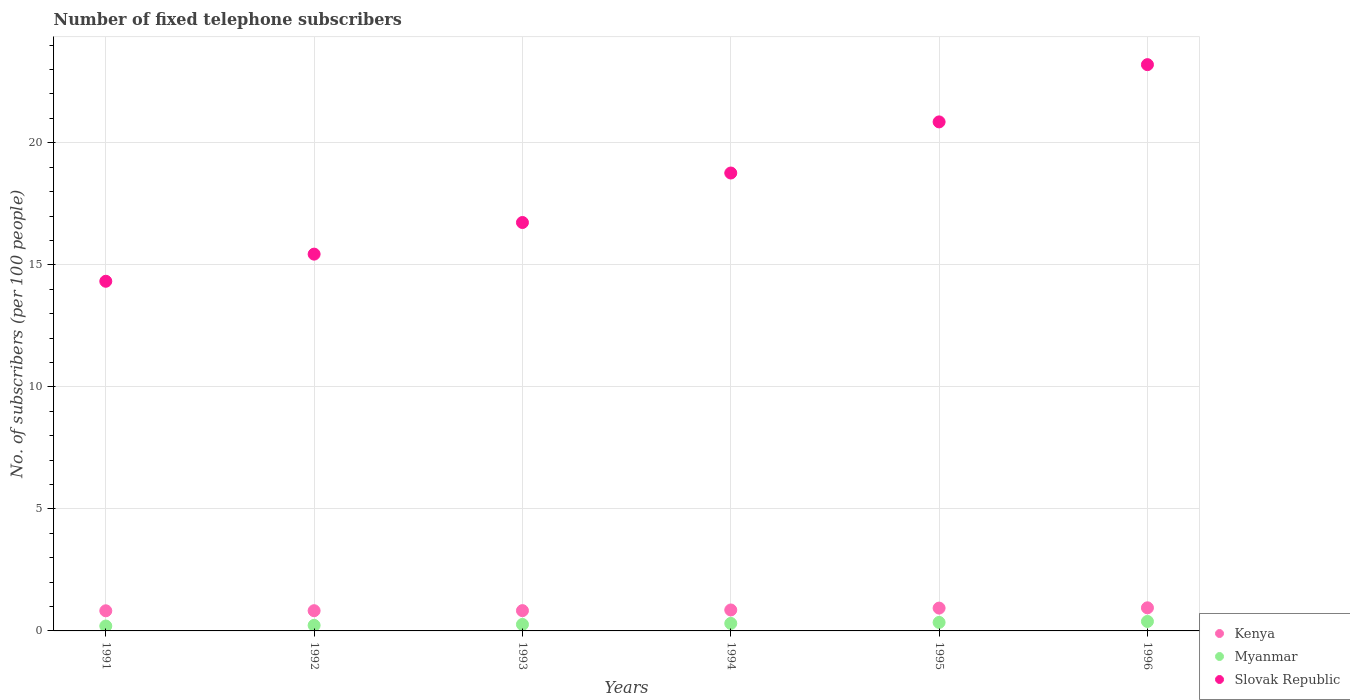How many different coloured dotlines are there?
Your answer should be very brief. 3. What is the number of fixed telephone subscribers in Slovak Republic in 1991?
Ensure brevity in your answer.  14.33. Across all years, what is the maximum number of fixed telephone subscribers in Kenya?
Offer a terse response. 0.95. Across all years, what is the minimum number of fixed telephone subscribers in Myanmar?
Provide a succinct answer. 0.2. In which year was the number of fixed telephone subscribers in Slovak Republic maximum?
Your response must be concise. 1996. What is the total number of fixed telephone subscribers in Kenya in the graph?
Your response must be concise. 5.22. What is the difference between the number of fixed telephone subscribers in Kenya in 1991 and that in 1994?
Offer a very short reply. -0.03. What is the difference between the number of fixed telephone subscribers in Kenya in 1995 and the number of fixed telephone subscribers in Myanmar in 1996?
Ensure brevity in your answer.  0.55. What is the average number of fixed telephone subscribers in Slovak Republic per year?
Keep it short and to the point. 18.22. In the year 1992, what is the difference between the number of fixed telephone subscribers in Myanmar and number of fixed telephone subscribers in Kenya?
Offer a terse response. -0.6. In how many years, is the number of fixed telephone subscribers in Kenya greater than 22?
Offer a very short reply. 0. What is the ratio of the number of fixed telephone subscribers in Kenya in 1993 to that in 1994?
Give a very brief answer. 0.97. Is the number of fixed telephone subscribers in Slovak Republic in 1991 less than that in 1994?
Your answer should be compact. Yes. Is the difference between the number of fixed telephone subscribers in Myanmar in 1991 and 1995 greater than the difference between the number of fixed telephone subscribers in Kenya in 1991 and 1995?
Offer a terse response. No. What is the difference between the highest and the second highest number of fixed telephone subscribers in Myanmar?
Provide a succinct answer. 0.04. What is the difference between the highest and the lowest number of fixed telephone subscribers in Kenya?
Your response must be concise. 0.12. In how many years, is the number of fixed telephone subscribers in Myanmar greater than the average number of fixed telephone subscribers in Myanmar taken over all years?
Your answer should be compact. 3. Is it the case that in every year, the sum of the number of fixed telephone subscribers in Kenya and number of fixed telephone subscribers in Myanmar  is greater than the number of fixed telephone subscribers in Slovak Republic?
Offer a very short reply. No. Is the number of fixed telephone subscribers in Kenya strictly greater than the number of fixed telephone subscribers in Slovak Republic over the years?
Provide a short and direct response. No. Is the number of fixed telephone subscribers in Slovak Republic strictly less than the number of fixed telephone subscribers in Kenya over the years?
Make the answer very short. No. How many years are there in the graph?
Your answer should be compact. 6. What is the difference between two consecutive major ticks on the Y-axis?
Provide a succinct answer. 5. Are the values on the major ticks of Y-axis written in scientific E-notation?
Your answer should be compact. No. Does the graph contain grids?
Provide a short and direct response. Yes. Where does the legend appear in the graph?
Make the answer very short. Bottom right. How many legend labels are there?
Give a very brief answer. 3. How are the legend labels stacked?
Offer a terse response. Vertical. What is the title of the graph?
Give a very brief answer. Number of fixed telephone subscribers. What is the label or title of the Y-axis?
Offer a very short reply. No. of subscribers (per 100 people). What is the No. of subscribers (per 100 people) of Kenya in 1991?
Your answer should be compact. 0.83. What is the No. of subscribers (per 100 people) in Myanmar in 1991?
Ensure brevity in your answer.  0.2. What is the No. of subscribers (per 100 people) of Slovak Republic in 1991?
Your response must be concise. 14.33. What is the No. of subscribers (per 100 people) in Kenya in 1992?
Provide a short and direct response. 0.83. What is the No. of subscribers (per 100 people) of Myanmar in 1992?
Your answer should be very brief. 0.23. What is the No. of subscribers (per 100 people) in Slovak Republic in 1992?
Keep it short and to the point. 15.44. What is the No. of subscribers (per 100 people) of Kenya in 1993?
Offer a very short reply. 0.83. What is the No. of subscribers (per 100 people) of Myanmar in 1993?
Your response must be concise. 0.27. What is the No. of subscribers (per 100 people) in Slovak Republic in 1993?
Offer a very short reply. 16.73. What is the No. of subscribers (per 100 people) in Kenya in 1994?
Offer a terse response. 0.86. What is the No. of subscribers (per 100 people) in Myanmar in 1994?
Make the answer very short. 0.31. What is the No. of subscribers (per 100 people) in Slovak Republic in 1994?
Offer a terse response. 18.76. What is the No. of subscribers (per 100 people) in Kenya in 1995?
Keep it short and to the point. 0.94. What is the No. of subscribers (per 100 people) of Myanmar in 1995?
Give a very brief answer. 0.35. What is the No. of subscribers (per 100 people) in Slovak Republic in 1995?
Offer a very short reply. 20.86. What is the No. of subscribers (per 100 people) of Kenya in 1996?
Your answer should be compact. 0.95. What is the No. of subscribers (per 100 people) of Myanmar in 1996?
Make the answer very short. 0.39. What is the No. of subscribers (per 100 people) of Slovak Republic in 1996?
Offer a very short reply. 23.2. Across all years, what is the maximum No. of subscribers (per 100 people) of Kenya?
Offer a terse response. 0.95. Across all years, what is the maximum No. of subscribers (per 100 people) in Myanmar?
Ensure brevity in your answer.  0.39. Across all years, what is the maximum No. of subscribers (per 100 people) of Slovak Republic?
Make the answer very short. 23.2. Across all years, what is the minimum No. of subscribers (per 100 people) of Kenya?
Make the answer very short. 0.83. Across all years, what is the minimum No. of subscribers (per 100 people) of Myanmar?
Your response must be concise. 0.2. Across all years, what is the minimum No. of subscribers (per 100 people) of Slovak Republic?
Your answer should be compact. 14.33. What is the total No. of subscribers (per 100 people) in Kenya in the graph?
Your answer should be compact. 5.22. What is the total No. of subscribers (per 100 people) in Myanmar in the graph?
Offer a terse response. 1.74. What is the total No. of subscribers (per 100 people) in Slovak Republic in the graph?
Offer a terse response. 109.32. What is the difference between the No. of subscribers (per 100 people) of Kenya in 1991 and that in 1992?
Offer a very short reply. -0. What is the difference between the No. of subscribers (per 100 people) of Myanmar in 1991 and that in 1992?
Keep it short and to the point. -0.03. What is the difference between the No. of subscribers (per 100 people) in Slovak Republic in 1991 and that in 1992?
Offer a very short reply. -1.11. What is the difference between the No. of subscribers (per 100 people) of Kenya in 1991 and that in 1993?
Provide a succinct answer. -0.01. What is the difference between the No. of subscribers (per 100 people) in Myanmar in 1991 and that in 1993?
Offer a very short reply. -0.07. What is the difference between the No. of subscribers (per 100 people) of Slovak Republic in 1991 and that in 1993?
Make the answer very short. -2.41. What is the difference between the No. of subscribers (per 100 people) of Kenya in 1991 and that in 1994?
Your answer should be very brief. -0.03. What is the difference between the No. of subscribers (per 100 people) in Myanmar in 1991 and that in 1994?
Provide a short and direct response. -0.11. What is the difference between the No. of subscribers (per 100 people) in Slovak Republic in 1991 and that in 1994?
Provide a short and direct response. -4.44. What is the difference between the No. of subscribers (per 100 people) in Kenya in 1991 and that in 1995?
Your answer should be compact. -0.11. What is the difference between the No. of subscribers (per 100 people) of Myanmar in 1991 and that in 1995?
Provide a succinct answer. -0.15. What is the difference between the No. of subscribers (per 100 people) of Slovak Republic in 1991 and that in 1995?
Keep it short and to the point. -6.53. What is the difference between the No. of subscribers (per 100 people) of Kenya in 1991 and that in 1996?
Offer a very short reply. -0.12. What is the difference between the No. of subscribers (per 100 people) of Myanmar in 1991 and that in 1996?
Offer a very short reply. -0.19. What is the difference between the No. of subscribers (per 100 people) in Slovak Republic in 1991 and that in 1996?
Give a very brief answer. -8.88. What is the difference between the No. of subscribers (per 100 people) in Kenya in 1992 and that in 1993?
Offer a very short reply. -0. What is the difference between the No. of subscribers (per 100 people) in Myanmar in 1992 and that in 1993?
Your answer should be compact. -0.04. What is the difference between the No. of subscribers (per 100 people) of Slovak Republic in 1992 and that in 1993?
Your answer should be very brief. -1.3. What is the difference between the No. of subscribers (per 100 people) in Kenya in 1992 and that in 1994?
Offer a terse response. -0.03. What is the difference between the No. of subscribers (per 100 people) in Myanmar in 1992 and that in 1994?
Your response must be concise. -0.08. What is the difference between the No. of subscribers (per 100 people) in Slovak Republic in 1992 and that in 1994?
Make the answer very short. -3.32. What is the difference between the No. of subscribers (per 100 people) of Kenya in 1992 and that in 1995?
Provide a succinct answer. -0.11. What is the difference between the No. of subscribers (per 100 people) of Myanmar in 1992 and that in 1995?
Provide a succinct answer. -0.12. What is the difference between the No. of subscribers (per 100 people) of Slovak Republic in 1992 and that in 1995?
Offer a terse response. -5.42. What is the difference between the No. of subscribers (per 100 people) of Kenya in 1992 and that in 1996?
Make the answer very short. -0.12. What is the difference between the No. of subscribers (per 100 people) in Myanmar in 1992 and that in 1996?
Make the answer very short. -0.16. What is the difference between the No. of subscribers (per 100 people) in Slovak Republic in 1992 and that in 1996?
Provide a short and direct response. -7.76. What is the difference between the No. of subscribers (per 100 people) of Kenya in 1993 and that in 1994?
Your response must be concise. -0.03. What is the difference between the No. of subscribers (per 100 people) of Myanmar in 1993 and that in 1994?
Give a very brief answer. -0.04. What is the difference between the No. of subscribers (per 100 people) in Slovak Republic in 1993 and that in 1994?
Offer a very short reply. -2.03. What is the difference between the No. of subscribers (per 100 people) of Kenya in 1993 and that in 1995?
Your answer should be compact. -0.1. What is the difference between the No. of subscribers (per 100 people) of Myanmar in 1993 and that in 1995?
Provide a short and direct response. -0.08. What is the difference between the No. of subscribers (per 100 people) of Slovak Republic in 1993 and that in 1995?
Offer a terse response. -4.12. What is the difference between the No. of subscribers (per 100 people) in Kenya in 1993 and that in 1996?
Provide a succinct answer. -0.12. What is the difference between the No. of subscribers (per 100 people) of Myanmar in 1993 and that in 1996?
Offer a terse response. -0.12. What is the difference between the No. of subscribers (per 100 people) of Slovak Republic in 1993 and that in 1996?
Provide a short and direct response. -6.47. What is the difference between the No. of subscribers (per 100 people) of Kenya in 1994 and that in 1995?
Provide a succinct answer. -0.08. What is the difference between the No. of subscribers (per 100 people) in Myanmar in 1994 and that in 1995?
Make the answer very short. -0.04. What is the difference between the No. of subscribers (per 100 people) of Slovak Republic in 1994 and that in 1995?
Your response must be concise. -2.09. What is the difference between the No. of subscribers (per 100 people) of Kenya in 1994 and that in 1996?
Your answer should be very brief. -0.09. What is the difference between the No. of subscribers (per 100 people) in Myanmar in 1994 and that in 1996?
Your answer should be compact. -0.08. What is the difference between the No. of subscribers (per 100 people) of Slovak Republic in 1994 and that in 1996?
Your answer should be very brief. -4.44. What is the difference between the No. of subscribers (per 100 people) in Kenya in 1995 and that in 1996?
Provide a short and direct response. -0.01. What is the difference between the No. of subscribers (per 100 people) of Myanmar in 1995 and that in 1996?
Your response must be concise. -0.04. What is the difference between the No. of subscribers (per 100 people) in Slovak Republic in 1995 and that in 1996?
Your answer should be very brief. -2.35. What is the difference between the No. of subscribers (per 100 people) in Kenya in 1991 and the No. of subscribers (per 100 people) in Myanmar in 1992?
Keep it short and to the point. 0.6. What is the difference between the No. of subscribers (per 100 people) of Kenya in 1991 and the No. of subscribers (per 100 people) of Slovak Republic in 1992?
Your answer should be very brief. -14.61. What is the difference between the No. of subscribers (per 100 people) of Myanmar in 1991 and the No. of subscribers (per 100 people) of Slovak Republic in 1992?
Ensure brevity in your answer.  -15.24. What is the difference between the No. of subscribers (per 100 people) of Kenya in 1991 and the No. of subscribers (per 100 people) of Myanmar in 1993?
Your answer should be compact. 0.56. What is the difference between the No. of subscribers (per 100 people) in Kenya in 1991 and the No. of subscribers (per 100 people) in Slovak Republic in 1993?
Offer a very short reply. -15.91. What is the difference between the No. of subscribers (per 100 people) in Myanmar in 1991 and the No. of subscribers (per 100 people) in Slovak Republic in 1993?
Your answer should be compact. -16.53. What is the difference between the No. of subscribers (per 100 people) in Kenya in 1991 and the No. of subscribers (per 100 people) in Myanmar in 1994?
Your answer should be very brief. 0.52. What is the difference between the No. of subscribers (per 100 people) in Kenya in 1991 and the No. of subscribers (per 100 people) in Slovak Republic in 1994?
Your answer should be very brief. -17.94. What is the difference between the No. of subscribers (per 100 people) of Myanmar in 1991 and the No. of subscribers (per 100 people) of Slovak Republic in 1994?
Make the answer very short. -18.56. What is the difference between the No. of subscribers (per 100 people) in Kenya in 1991 and the No. of subscribers (per 100 people) in Myanmar in 1995?
Offer a terse response. 0.48. What is the difference between the No. of subscribers (per 100 people) in Kenya in 1991 and the No. of subscribers (per 100 people) in Slovak Republic in 1995?
Your answer should be compact. -20.03. What is the difference between the No. of subscribers (per 100 people) in Myanmar in 1991 and the No. of subscribers (per 100 people) in Slovak Republic in 1995?
Provide a succinct answer. -20.65. What is the difference between the No. of subscribers (per 100 people) of Kenya in 1991 and the No. of subscribers (per 100 people) of Myanmar in 1996?
Offer a very short reply. 0.44. What is the difference between the No. of subscribers (per 100 people) of Kenya in 1991 and the No. of subscribers (per 100 people) of Slovak Republic in 1996?
Make the answer very short. -22.38. What is the difference between the No. of subscribers (per 100 people) in Myanmar in 1991 and the No. of subscribers (per 100 people) in Slovak Republic in 1996?
Make the answer very short. -23. What is the difference between the No. of subscribers (per 100 people) of Kenya in 1992 and the No. of subscribers (per 100 people) of Myanmar in 1993?
Make the answer very short. 0.56. What is the difference between the No. of subscribers (per 100 people) of Kenya in 1992 and the No. of subscribers (per 100 people) of Slovak Republic in 1993?
Your answer should be very brief. -15.91. What is the difference between the No. of subscribers (per 100 people) in Myanmar in 1992 and the No. of subscribers (per 100 people) in Slovak Republic in 1993?
Provide a succinct answer. -16.51. What is the difference between the No. of subscribers (per 100 people) of Kenya in 1992 and the No. of subscribers (per 100 people) of Myanmar in 1994?
Provide a short and direct response. 0.52. What is the difference between the No. of subscribers (per 100 people) in Kenya in 1992 and the No. of subscribers (per 100 people) in Slovak Republic in 1994?
Offer a very short reply. -17.93. What is the difference between the No. of subscribers (per 100 people) in Myanmar in 1992 and the No. of subscribers (per 100 people) in Slovak Republic in 1994?
Your answer should be compact. -18.53. What is the difference between the No. of subscribers (per 100 people) of Kenya in 1992 and the No. of subscribers (per 100 people) of Myanmar in 1995?
Offer a terse response. 0.48. What is the difference between the No. of subscribers (per 100 people) of Kenya in 1992 and the No. of subscribers (per 100 people) of Slovak Republic in 1995?
Ensure brevity in your answer.  -20.03. What is the difference between the No. of subscribers (per 100 people) of Myanmar in 1992 and the No. of subscribers (per 100 people) of Slovak Republic in 1995?
Your response must be concise. -20.63. What is the difference between the No. of subscribers (per 100 people) in Kenya in 1992 and the No. of subscribers (per 100 people) in Myanmar in 1996?
Ensure brevity in your answer.  0.44. What is the difference between the No. of subscribers (per 100 people) in Kenya in 1992 and the No. of subscribers (per 100 people) in Slovak Republic in 1996?
Provide a succinct answer. -22.37. What is the difference between the No. of subscribers (per 100 people) of Myanmar in 1992 and the No. of subscribers (per 100 people) of Slovak Republic in 1996?
Provide a short and direct response. -22.97. What is the difference between the No. of subscribers (per 100 people) in Kenya in 1993 and the No. of subscribers (per 100 people) in Myanmar in 1994?
Ensure brevity in your answer.  0.52. What is the difference between the No. of subscribers (per 100 people) of Kenya in 1993 and the No. of subscribers (per 100 people) of Slovak Republic in 1994?
Offer a very short reply. -17.93. What is the difference between the No. of subscribers (per 100 people) in Myanmar in 1993 and the No. of subscribers (per 100 people) in Slovak Republic in 1994?
Your answer should be very brief. -18.49. What is the difference between the No. of subscribers (per 100 people) of Kenya in 1993 and the No. of subscribers (per 100 people) of Myanmar in 1995?
Give a very brief answer. 0.48. What is the difference between the No. of subscribers (per 100 people) of Kenya in 1993 and the No. of subscribers (per 100 people) of Slovak Republic in 1995?
Your answer should be very brief. -20.02. What is the difference between the No. of subscribers (per 100 people) in Myanmar in 1993 and the No. of subscribers (per 100 people) in Slovak Republic in 1995?
Provide a short and direct response. -20.59. What is the difference between the No. of subscribers (per 100 people) of Kenya in 1993 and the No. of subscribers (per 100 people) of Myanmar in 1996?
Ensure brevity in your answer.  0.44. What is the difference between the No. of subscribers (per 100 people) of Kenya in 1993 and the No. of subscribers (per 100 people) of Slovak Republic in 1996?
Ensure brevity in your answer.  -22.37. What is the difference between the No. of subscribers (per 100 people) of Myanmar in 1993 and the No. of subscribers (per 100 people) of Slovak Republic in 1996?
Offer a very short reply. -22.94. What is the difference between the No. of subscribers (per 100 people) in Kenya in 1994 and the No. of subscribers (per 100 people) in Myanmar in 1995?
Provide a succinct answer. 0.51. What is the difference between the No. of subscribers (per 100 people) of Kenya in 1994 and the No. of subscribers (per 100 people) of Slovak Republic in 1995?
Provide a short and direct response. -20. What is the difference between the No. of subscribers (per 100 people) in Myanmar in 1994 and the No. of subscribers (per 100 people) in Slovak Republic in 1995?
Make the answer very short. -20.55. What is the difference between the No. of subscribers (per 100 people) in Kenya in 1994 and the No. of subscribers (per 100 people) in Myanmar in 1996?
Your response must be concise. 0.47. What is the difference between the No. of subscribers (per 100 people) in Kenya in 1994 and the No. of subscribers (per 100 people) in Slovak Republic in 1996?
Give a very brief answer. -22.34. What is the difference between the No. of subscribers (per 100 people) in Myanmar in 1994 and the No. of subscribers (per 100 people) in Slovak Republic in 1996?
Keep it short and to the point. -22.89. What is the difference between the No. of subscribers (per 100 people) of Kenya in 1995 and the No. of subscribers (per 100 people) of Myanmar in 1996?
Your answer should be compact. 0.55. What is the difference between the No. of subscribers (per 100 people) of Kenya in 1995 and the No. of subscribers (per 100 people) of Slovak Republic in 1996?
Provide a succinct answer. -22.27. What is the difference between the No. of subscribers (per 100 people) in Myanmar in 1995 and the No. of subscribers (per 100 people) in Slovak Republic in 1996?
Keep it short and to the point. -22.85. What is the average No. of subscribers (per 100 people) in Kenya per year?
Offer a very short reply. 0.87. What is the average No. of subscribers (per 100 people) in Myanmar per year?
Your answer should be very brief. 0.29. What is the average No. of subscribers (per 100 people) of Slovak Republic per year?
Offer a very short reply. 18.22. In the year 1991, what is the difference between the No. of subscribers (per 100 people) in Kenya and No. of subscribers (per 100 people) in Myanmar?
Your answer should be compact. 0.62. In the year 1991, what is the difference between the No. of subscribers (per 100 people) of Kenya and No. of subscribers (per 100 people) of Slovak Republic?
Keep it short and to the point. -13.5. In the year 1991, what is the difference between the No. of subscribers (per 100 people) in Myanmar and No. of subscribers (per 100 people) in Slovak Republic?
Your response must be concise. -14.13. In the year 1992, what is the difference between the No. of subscribers (per 100 people) of Kenya and No. of subscribers (per 100 people) of Myanmar?
Your answer should be very brief. 0.6. In the year 1992, what is the difference between the No. of subscribers (per 100 people) in Kenya and No. of subscribers (per 100 people) in Slovak Republic?
Make the answer very short. -14.61. In the year 1992, what is the difference between the No. of subscribers (per 100 people) of Myanmar and No. of subscribers (per 100 people) of Slovak Republic?
Your answer should be compact. -15.21. In the year 1993, what is the difference between the No. of subscribers (per 100 people) in Kenya and No. of subscribers (per 100 people) in Myanmar?
Offer a very short reply. 0.56. In the year 1993, what is the difference between the No. of subscribers (per 100 people) in Kenya and No. of subscribers (per 100 people) in Slovak Republic?
Offer a very short reply. -15.9. In the year 1993, what is the difference between the No. of subscribers (per 100 people) of Myanmar and No. of subscribers (per 100 people) of Slovak Republic?
Offer a very short reply. -16.47. In the year 1994, what is the difference between the No. of subscribers (per 100 people) of Kenya and No. of subscribers (per 100 people) of Myanmar?
Offer a very short reply. 0.55. In the year 1994, what is the difference between the No. of subscribers (per 100 people) in Kenya and No. of subscribers (per 100 people) in Slovak Republic?
Keep it short and to the point. -17.9. In the year 1994, what is the difference between the No. of subscribers (per 100 people) of Myanmar and No. of subscribers (per 100 people) of Slovak Republic?
Provide a succinct answer. -18.45. In the year 1995, what is the difference between the No. of subscribers (per 100 people) of Kenya and No. of subscribers (per 100 people) of Myanmar?
Give a very brief answer. 0.59. In the year 1995, what is the difference between the No. of subscribers (per 100 people) of Kenya and No. of subscribers (per 100 people) of Slovak Republic?
Keep it short and to the point. -19.92. In the year 1995, what is the difference between the No. of subscribers (per 100 people) in Myanmar and No. of subscribers (per 100 people) in Slovak Republic?
Offer a very short reply. -20.51. In the year 1996, what is the difference between the No. of subscribers (per 100 people) of Kenya and No. of subscribers (per 100 people) of Myanmar?
Keep it short and to the point. 0.56. In the year 1996, what is the difference between the No. of subscribers (per 100 people) of Kenya and No. of subscribers (per 100 people) of Slovak Republic?
Your response must be concise. -22.26. In the year 1996, what is the difference between the No. of subscribers (per 100 people) in Myanmar and No. of subscribers (per 100 people) in Slovak Republic?
Your response must be concise. -22.81. What is the ratio of the No. of subscribers (per 100 people) of Kenya in 1991 to that in 1992?
Provide a succinct answer. 1. What is the ratio of the No. of subscribers (per 100 people) in Myanmar in 1991 to that in 1992?
Ensure brevity in your answer.  0.88. What is the ratio of the No. of subscribers (per 100 people) of Slovak Republic in 1991 to that in 1992?
Your answer should be compact. 0.93. What is the ratio of the No. of subscribers (per 100 people) in Myanmar in 1991 to that in 1993?
Provide a short and direct response. 0.75. What is the ratio of the No. of subscribers (per 100 people) of Slovak Republic in 1991 to that in 1993?
Offer a terse response. 0.86. What is the ratio of the No. of subscribers (per 100 people) of Kenya in 1991 to that in 1994?
Provide a succinct answer. 0.96. What is the ratio of the No. of subscribers (per 100 people) in Myanmar in 1991 to that in 1994?
Make the answer very short. 0.65. What is the ratio of the No. of subscribers (per 100 people) of Slovak Republic in 1991 to that in 1994?
Provide a succinct answer. 0.76. What is the ratio of the No. of subscribers (per 100 people) of Kenya in 1991 to that in 1995?
Give a very brief answer. 0.88. What is the ratio of the No. of subscribers (per 100 people) in Myanmar in 1991 to that in 1995?
Your answer should be very brief. 0.58. What is the ratio of the No. of subscribers (per 100 people) in Slovak Republic in 1991 to that in 1995?
Your answer should be very brief. 0.69. What is the ratio of the No. of subscribers (per 100 people) of Kenya in 1991 to that in 1996?
Provide a short and direct response. 0.87. What is the ratio of the No. of subscribers (per 100 people) of Myanmar in 1991 to that in 1996?
Your answer should be compact. 0.52. What is the ratio of the No. of subscribers (per 100 people) of Slovak Republic in 1991 to that in 1996?
Provide a succinct answer. 0.62. What is the ratio of the No. of subscribers (per 100 people) of Myanmar in 1992 to that in 1993?
Offer a terse response. 0.86. What is the ratio of the No. of subscribers (per 100 people) in Slovak Republic in 1992 to that in 1993?
Your answer should be very brief. 0.92. What is the ratio of the No. of subscribers (per 100 people) in Kenya in 1992 to that in 1994?
Ensure brevity in your answer.  0.97. What is the ratio of the No. of subscribers (per 100 people) of Myanmar in 1992 to that in 1994?
Keep it short and to the point. 0.74. What is the ratio of the No. of subscribers (per 100 people) in Slovak Republic in 1992 to that in 1994?
Provide a succinct answer. 0.82. What is the ratio of the No. of subscribers (per 100 people) of Kenya in 1992 to that in 1995?
Give a very brief answer. 0.89. What is the ratio of the No. of subscribers (per 100 people) of Myanmar in 1992 to that in 1995?
Offer a terse response. 0.66. What is the ratio of the No. of subscribers (per 100 people) of Slovak Republic in 1992 to that in 1995?
Your response must be concise. 0.74. What is the ratio of the No. of subscribers (per 100 people) of Kenya in 1992 to that in 1996?
Provide a short and direct response. 0.88. What is the ratio of the No. of subscribers (per 100 people) in Myanmar in 1992 to that in 1996?
Ensure brevity in your answer.  0.59. What is the ratio of the No. of subscribers (per 100 people) in Slovak Republic in 1992 to that in 1996?
Provide a short and direct response. 0.67. What is the ratio of the No. of subscribers (per 100 people) in Kenya in 1993 to that in 1994?
Give a very brief answer. 0.97. What is the ratio of the No. of subscribers (per 100 people) of Myanmar in 1993 to that in 1994?
Your answer should be compact. 0.87. What is the ratio of the No. of subscribers (per 100 people) in Slovak Republic in 1993 to that in 1994?
Offer a very short reply. 0.89. What is the ratio of the No. of subscribers (per 100 people) in Kenya in 1993 to that in 1995?
Your answer should be compact. 0.89. What is the ratio of the No. of subscribers (per 100 people) in Myanmar in 1993 to that in 1995?
Keep it short and to the point. 0.76. What is the ratio of the No. of subscribers (per 100 people) of Slovak Republic in 1993 to that in 1995?
Make the answer very short. 0.8. What is the ratio of the No. of subscribers (per 100 people) of Kenya in 1993 to that in 1996?
Offer a very short reply. 0.88. What is the ratio of the No. of subscribers (per 100 people) of Myanmar in 1993 to that in 1996?
Your answer should be very brief. 0.69. What is the ratio of the No. of subscribers (per 100 people) of Slovak Republic in 1993 to that in 1996?
Ensure brevity in your answer.  0.72. What is the ratio of the No. of subscribers (per 100 people) of Kenya in 1994 to that in 1995?
Give a very brief answer. 0.92. What is the ratio of the No. of subscribers (per 100 people) of Myanmar in 1994 to that in 1995?
Give a very brief answer. 0.88. What is the ratio of the No. of subscribers (per 100 people) of Slovak Republic in 1994 to that in 1995?
Your answer should be very brief. 0.9. What is the ratio of the No. of subscribers (per 100 people) of Kenya in 1994 to that in 1996?
Offer a very short reply. 0.91. What is the ratio of the No. of subscribers (per 100 people) of Myanmar in 1994 to that in 1996?
Your answer should be very brief. 0.79. What is the ratio of the No. of subscribers (per 100 people) in Slovak Republic in 1994 to that in 1996?
Your answer should be compact. 0.81. What is the ratio of the No. of subscribers (per 100 people) of Myanmar in 1995 to that in 1996?
Make the answer very short. 0.9. What is the ratio of the No. of subscribers (per 100 people) of Slovak Republic in 1995 to that in 1996?
Provide a succinct answer. 0.9. What is the difference between the highest and the second highest No. of subscribers (per 100 people) in Kenya?
Offer a very short reply. 0.01. What is the difference between the highest and the second highest No. of subscribers (per 100 people) of Myanmar?
Make the answer very short. 0.04. What is the difference between the highest and the second highest No. of subscribers (per 100 people) in Slovak Republic?
Your answer should be very brief. 2.35. What is the difference between the highest and the lowest No. of subscribers (per 100 people) in Kenya?
Offer a terse response. 0.12. What is the difference between the highest and the lowest No. of subscribers (per 100 people) of Myanmar?
Provide a short and direct response. 0.19. What is the difference between the highest and the lowest No. of subscribers (per 100 people) of Slovak Republic?
Your response must be concise. 8.88. 